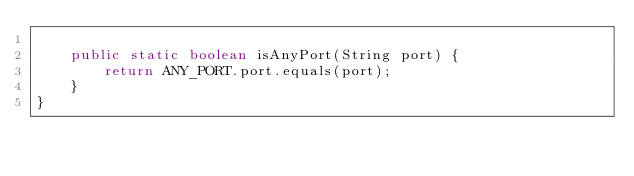<code> <loc_0><loc_0><loc_500><loc_500><_Java_>
    public static boolean isAnyPort(String port) {
        return ANY_PORT.port.equals(port);
    }
}
</code> 